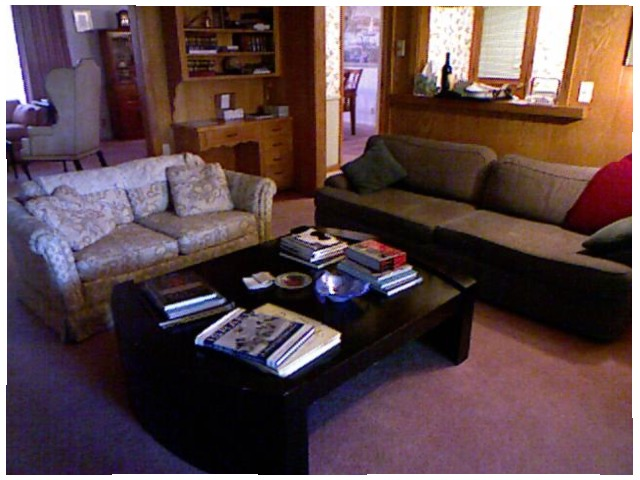<image>
Is there a table in front of the sofa? Yes. The table is positioned in front of the sofa, appearing closer to the camera viewpoint. Is the table on the book? No. The table is not positioned on the book. They may be near each other, but the table is not supported by or resting on top of the book. Where is the pillow in relation to the couch? Is it on the couch? No. The pillow is not positioned on the couch. They may be near each other, but the pillow is not supported by or resting on top of the couch. 